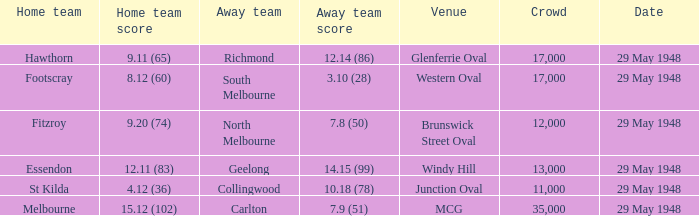In the match featuring footscray as the home side, what was their total score? 8.12 (60). 